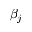<formula> <loc_0><loc_0><loc_500><loc_500>\beta _ { j }</formula> 